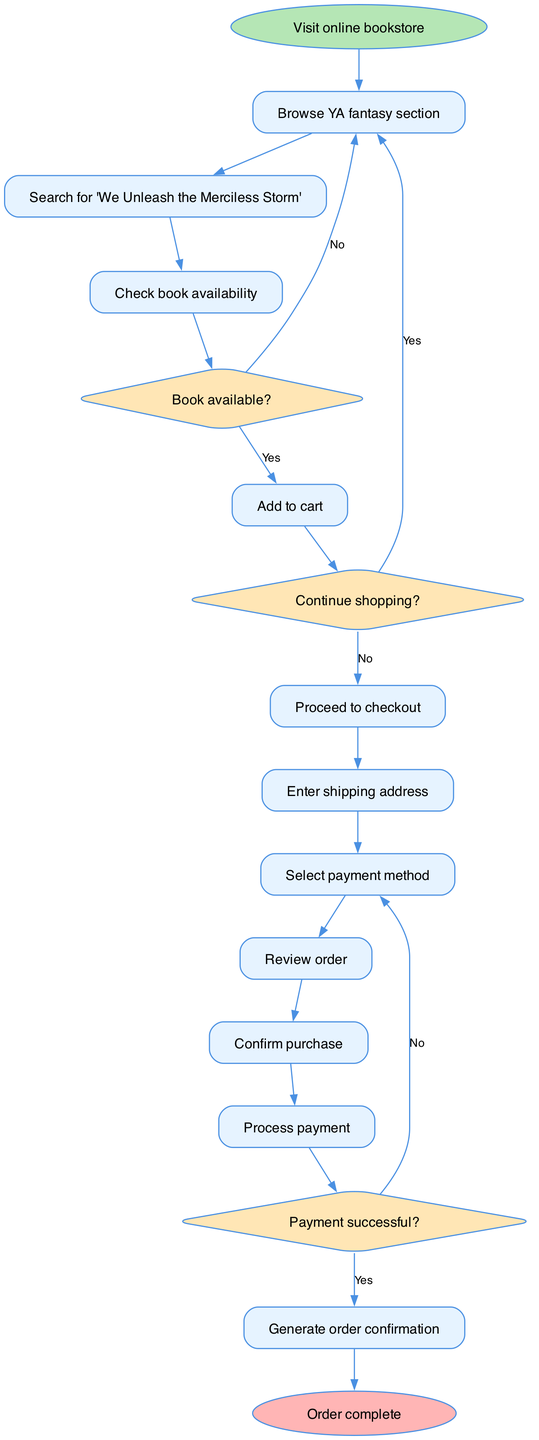What is the first step in the order processing flow? The first step according to the diagram is "Visit online bookstore." This is indicated by the starting node from which the flow begins.
Answer: Visit online bookstore How many decision nodes are present in the flowchart? The flowchart has three decision nodes. They correspond to the questions "Book available?", "Continue shopping?", and "Payment successful?"
Answer: 3 What happens if the book is not available? If the book is not available, the flow goes back to the "Browse YA fantasy section" node, allowing the user to continue searching for different books. This is shown by the edge connecting from the decision node to the browsing node.
Answer: Continue shopping What step comes immediately after adding a book to the cart? The step that comes immediately after adding a book to the cart is "Proceed to checkout." This is confirmed by the edge that connects the "Add to cart" node to the "Proceed to checkout" node in the sequence.
Answer: Proceed to checkout What is the final outcome of the flowchart? The final outcome of the flowchart is "Order complete." This is indicated by the end node in the flowchart where the process concludes after confirming the purchase and processing payment.
Answer: Order complete What will happen if the payment is unsuccessful? If the payment is unsuccessful, the flow returns back to the node "Select payment method," indicating that the user must select a different payment method to try again. This is shown by the edge from the decision node to the payment method selection node.
Answer: Select payment method What node follows the "Review order" step? The node that follows the "Review order" step is "Confirm purchase." This is confirmed by the direct edge connecting these two nodes in the flowchart.
Answer: Confirm purchase Which node indicates that the user has finished shopping? The node indicating that the user has finished shopping is "Continue shopping?" This is a decision node where the user decides whether to proceed with the current order or keep browsing.
Answer: Continue shopping? 